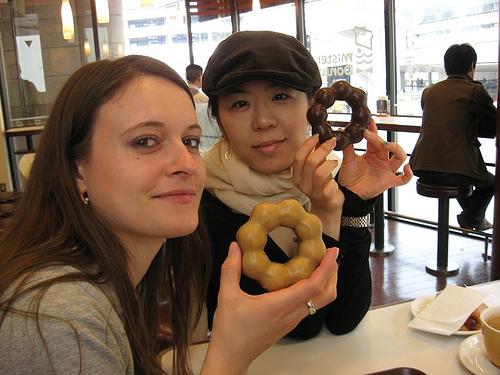What are they holding?
Give a very brief answer. Donuts. What food are they holding?
Write a very short answer. Donuts. Do they look happy?
Keep it brief. Yes. 